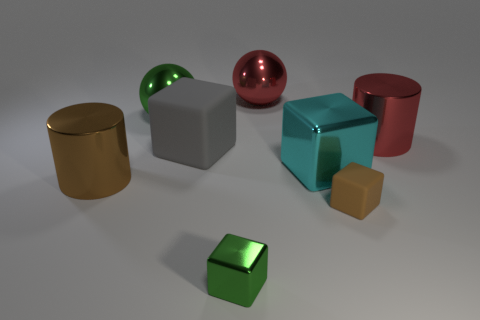Is the gray rubber thing the same shape as the cyan metallic thing?
Your answer should be compact. Yes. What number of things are big brown balls or big objects that are on the left side of the tiny green object?
Offer a terse response. 3. What number of small objects are there?
Give a very brief answer. 2. Is there a brown matte thing of the same size as the cyan object?
Your response must be concise. No. Is the number of gray rubber objects to the left of the brown rubber thing less than the number of cubes?
Your answer should be very brief. Yes. Do the cyan object and the gray matte object have the same size?
Make the answer very short. Yes. There is a cube that is made of the same material as the large cyan object; what is its size?
Keep it short and to the point. Small. How many metal things are the same color as the tiny metallic block?
Give a very brief answer. 1. Are there fewer large cubes that are in front of the small brown thing than big red objects behind the large green object?
Make the answer very short. Yes. There is a big red shiny thing that is right of the big red metal sphere; is its shape the same as the small green object?
Keep it short and to the point. No. 